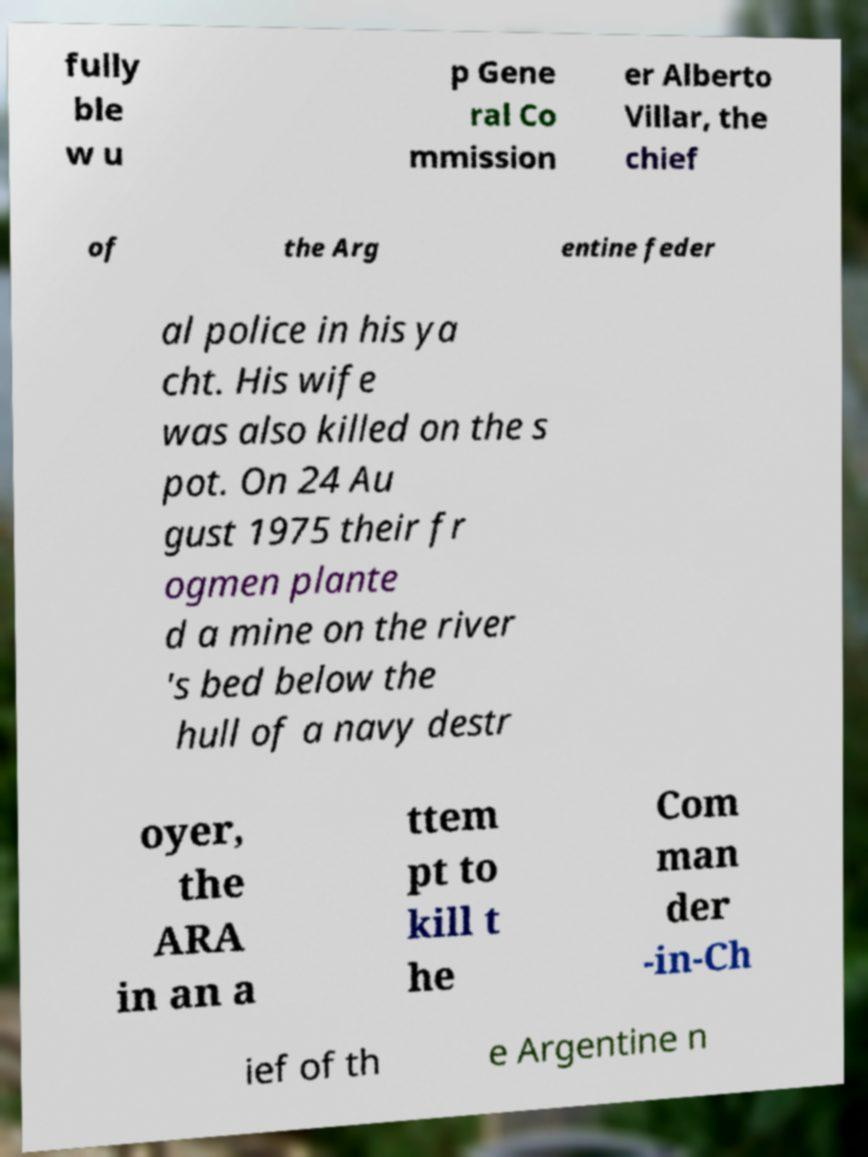Could you assist in decoding the text presented in this image and type it out clearly? fully ble w u p Gene ral Co mmission er Alberto Villar, the chief of the Arg entine feder al police in his ya cht. His wife was also killed on the s pot. On 24 Au gust 1975 their fr ogmen plante d a mine on the river 's bed below the hull of a navy destr oyer, the ARA in an a ttem pt to kill t he Com man der -in-Ch ief of th e Argentine n 